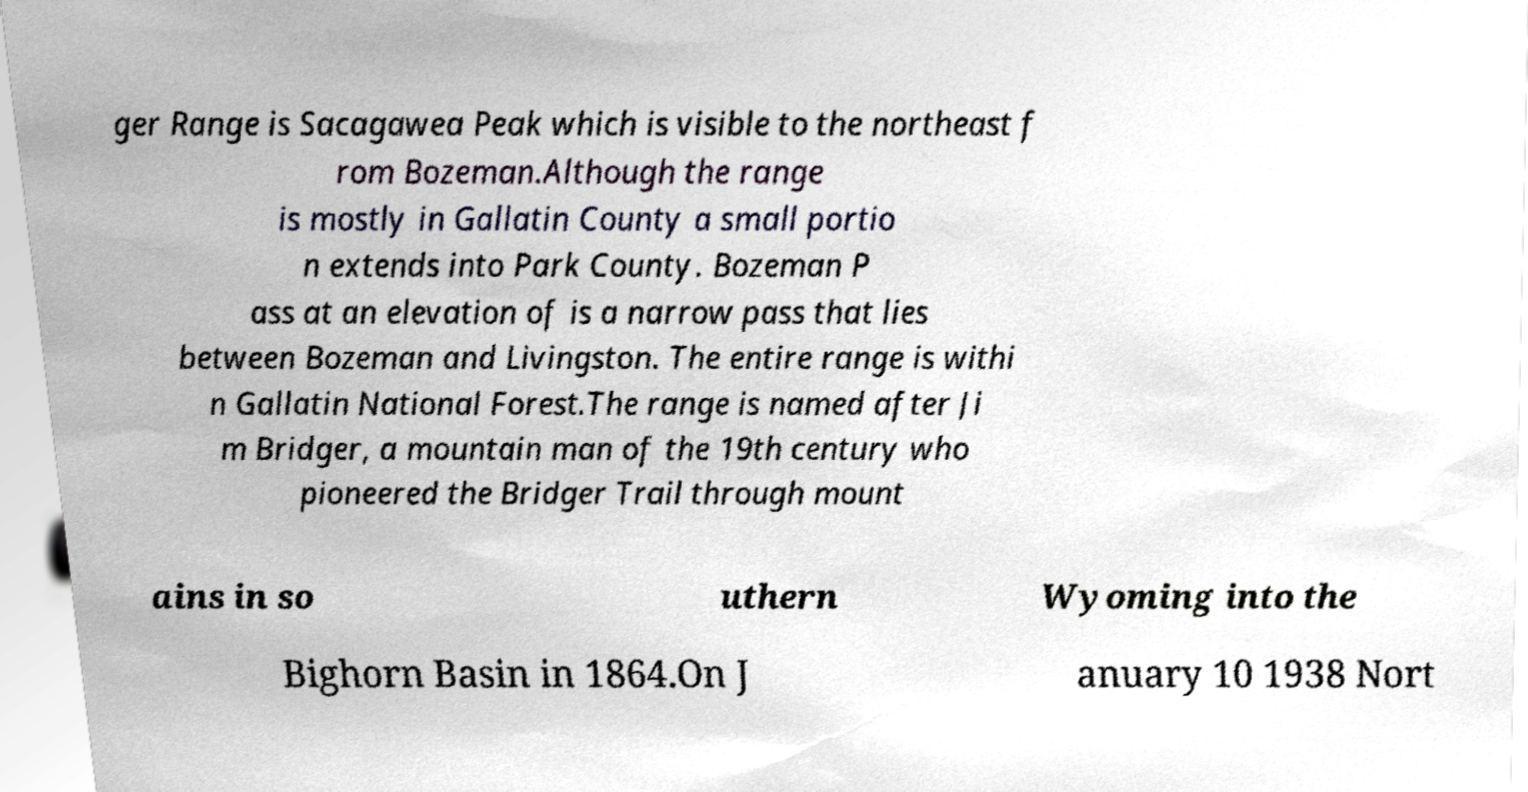Can you read and provide the text displayed in the image?This photo seems to have some interesting text. Can you extract and type it out for me? ger Range is Sacagawea Peak which is visible to the northeast f rom Bozeman.Although the range is mostly in Gallatin County a small portio n extends into Park County. Bozeman P ass at an elevation of is a narrow pass that lies between Bozeman and Livingston. The entire range is withi n Gallatin National Forest.The range is named after Ji m Bridger, a mountain man of the 19th century who pioneered the Bridger Trail through mount ains in so uthern Wyoming into the Bighorn Basin in 1864.On J anuary 10 1938 Nort 